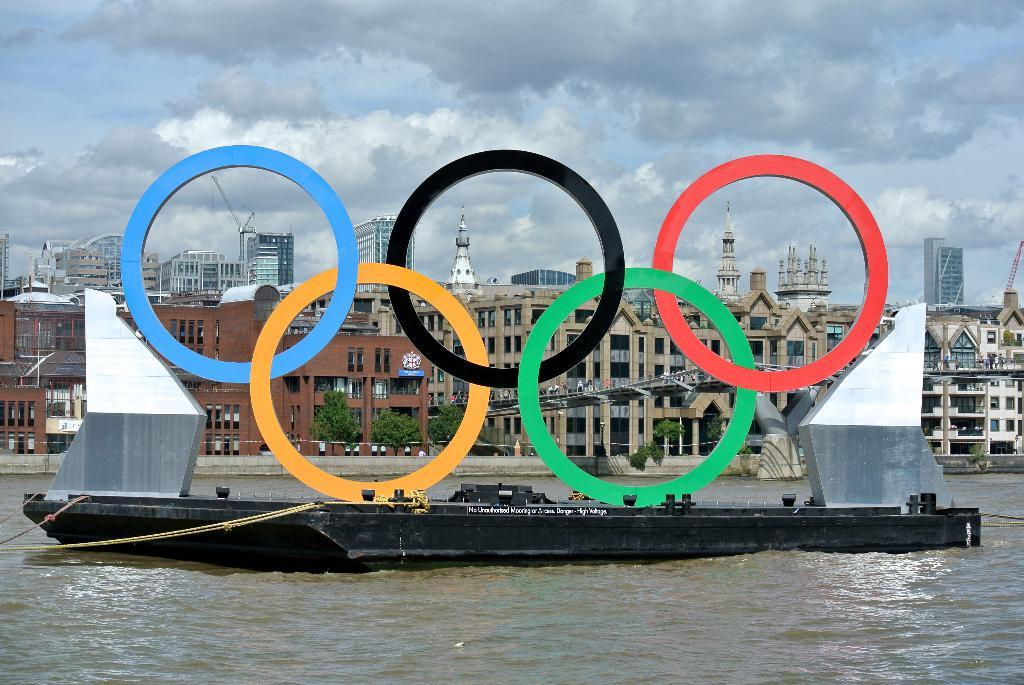What color is the boat in the image? The boat in the image is black-colored. What is at the bottom of the image? There is water at the bottom of the image. What can be seen in the background of the image? There are many buildings in the background of the image. What is visible in the sky at the top of the image? There are clouds in the sky at the top of the image. What type of plant is being used as evidence in a crime scene in the image? There is no plant or crime scene present in the image; it features a black-colored boat, water, buildings, and clouds. Can you tell me how many bears are visible in the image? There are no bears present in the image. 